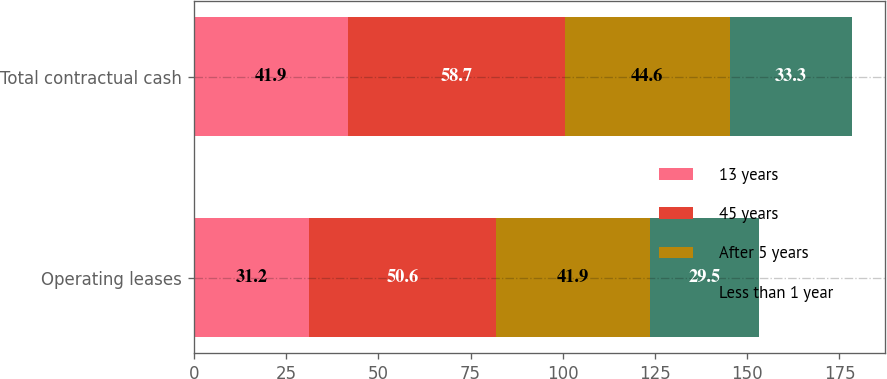Convert chart to OTSL. <chart><loc_0><loc_0><loc_500><loc_500><stacked_bar_chart><ecel><fcel>Operating leases<fcel>Total contractual cash<nl><fcel>13 years<fcel>31.2<fcel>41.9<nl><fcel>45 years<fcel>50.6<fcel>58.7<nl><fcel>After 5 years<fcel>41.9<fcel>44.6<nl><fcel>Less than 1 year<fcel>29.5<fcel>33.3<nl></chart> 